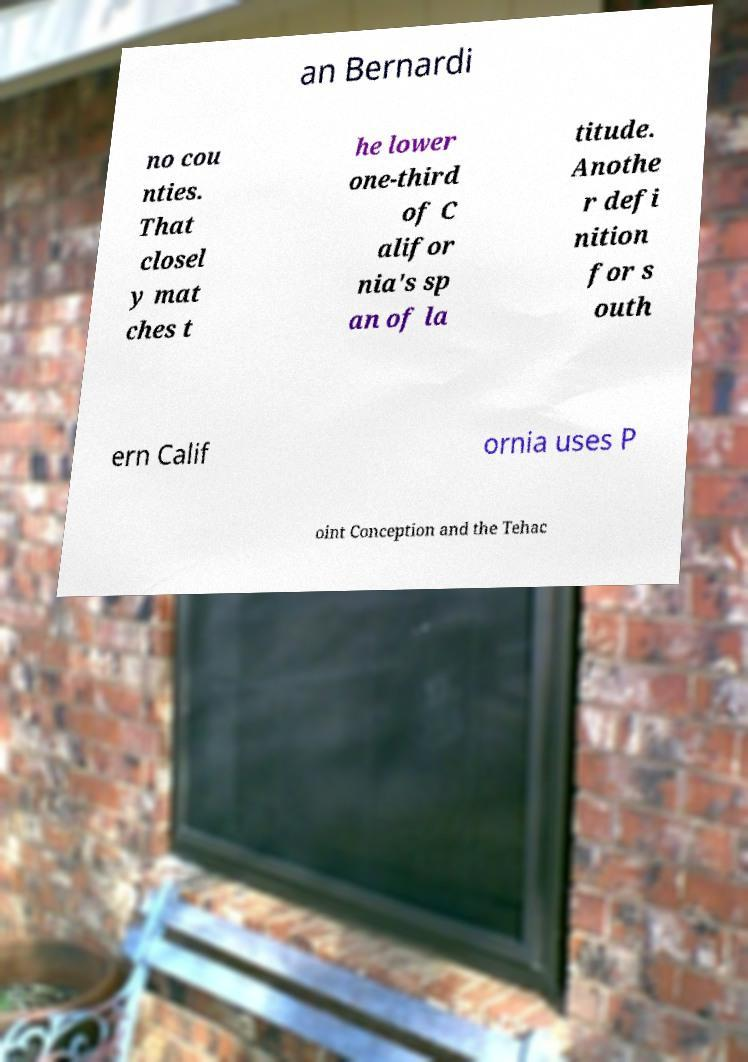Please identify and transcribe the text found in this image. an Bernardi no cou nties. That closel y mat ches t he lower one-third of C alifor nia's sp an of la titude. Anothe r defi nition for s outh ern Calif ornia uses P oint Conception and the Tehac 